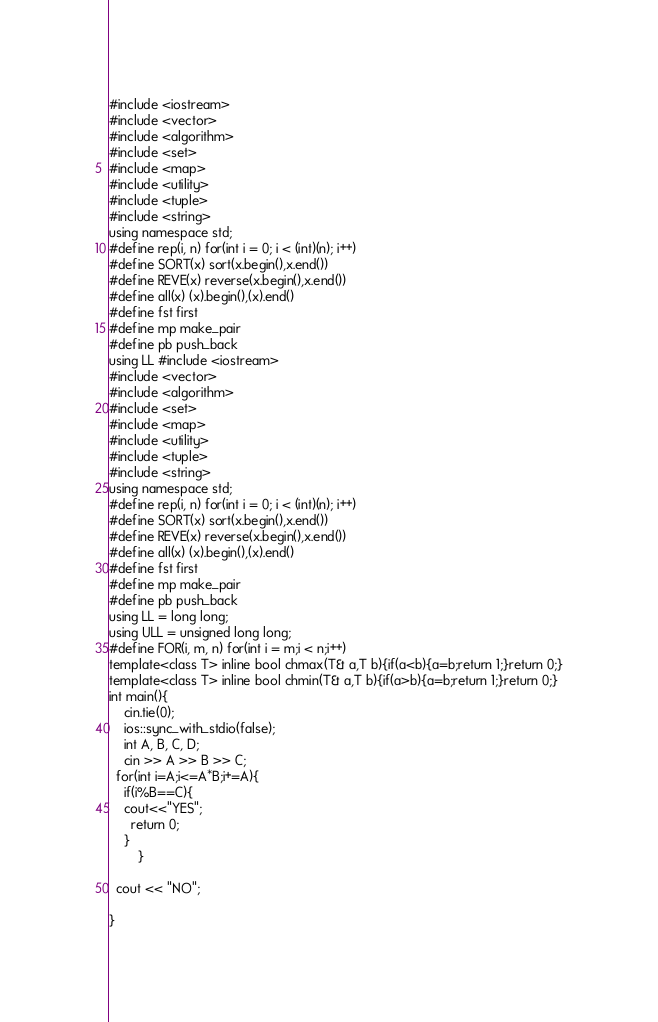Convert code to text. <code><loc_0><loc_0><loc_500><loc_500><_C++_>#include <iostream>
#include <vector>
#include <algorithm>
#include <set>
#include <map>
#include <utility>
#include <tuple>
#include <string>
using namespace std;
#define rep(i, n) for(int i = 0; i < (int)(n); i++)
#define SORT(x) sort(x.begin(),x.end())
#define REVE(x) reverse(x.begin(),x.end())
#define all(x) (x).begin(),(x).end()
#define fst first
#define mp make_pair
#define pb push_back
using LL #include <iostream>
#include <vector>
#include <algorithm>
#include <set>
#include <map>
#include <utility>
#include <tuple>
#include <string>
using namespace std;
#define rep(i, n) for(int i = 0; i < (int)(n); i++)
#define SORT(x) sort(x.begin(),x.end())
#define REVE(x) reverse(x.begin(),x.end())
#define all(x) (x).begin(),(x).end()
#define fst first
#define mp make_pair
#define pb push_back
using LL = long long;
using ULL = unsigned long long;
#define FOR(i, m, n) for(int i = m;i < n;i++)
template<class T> inline bool chmax(T& a,T b){if(a<b){a=b;return 1;}return 0;}
template<class T> inline bool chmin(T& a,T b){if(a>b){a=b;return 1;}return 0;}
int main(){
    cin.tie(0);
    ios::sync_with_stdio(false);
    int A, B, C, D;
    cin >> A >> B >> C;
  for(int i=A;i<=A*B;i+=A){
  	if(i%B==C){
  	cout<<"YES";
      return 0;
  	}
     	}
 
  cout << "NO";
  
}</code> 